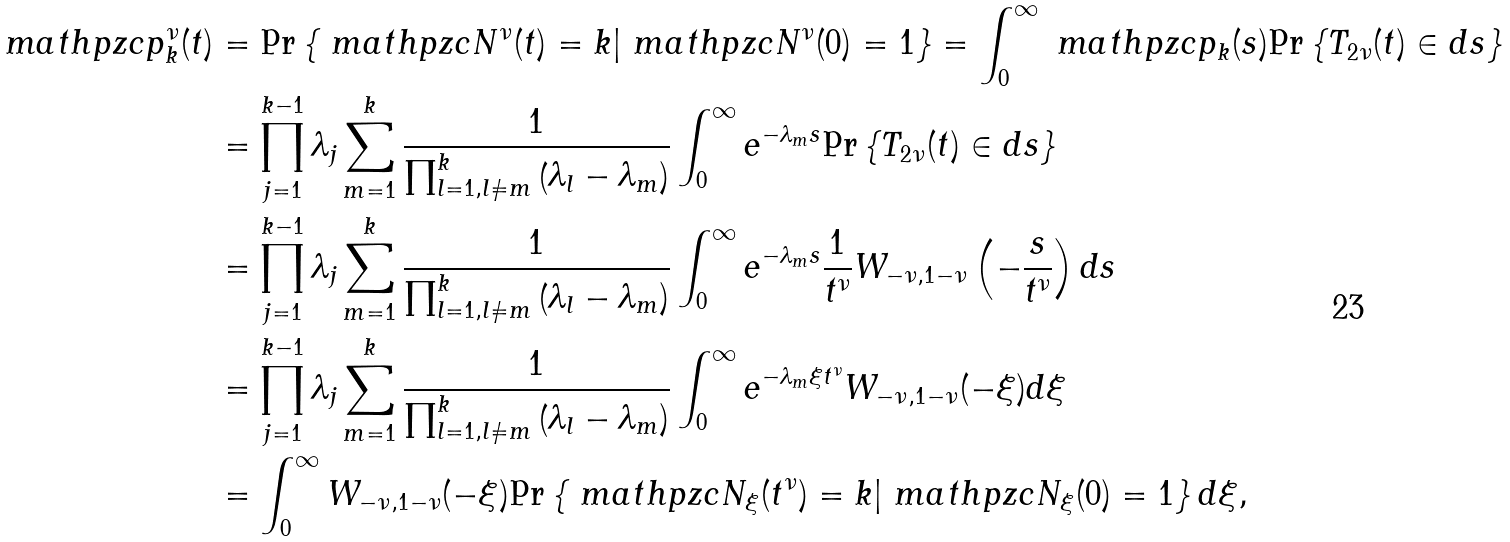<formula> <loc_0><loc_0><loc_500><loc_500>\ m a t h p z c { p } _ { k } ^ { \nu } ( t ) & = \text {Pr} \left \{ \ m a t h p z c { N } ^ { \nu } ( t ) = k | \ m a t h p z c { N } ^ { \nu } ( 0 ) = 1 \right \} = \int _ { 0 } ^ { \infty } \ m a t h p z c { p } _ { k } ( s ) \text {Pr} \left \{ T _ { 2 \nu } ( t ) \in d s \right \} \\ & = \prod _ { j = 1 } ^ { k - 1 } \lambda _ { j } \sum _ { m = 1 } ^ { k } \frac { 1 } { \prod _ { l = 1 , l \neq m } ^ { k } \left ( \lambda _ { l } - \lambda _ { m } \right ) } \int _ { 0 } ^ { \infty } e ^ { - \lambda _ { m } s } \text {Pr} \left \{ T _ { 2 \nu } ( t ) \in d s \right \} \\ & = \prod _ { j = 1 } ^ { k - 1 } \lambda _ { j } \sum _ { m = 1 } ^ { k } \frac { 1 } { \prod _ { l = 1 , l \neq m } ^ { k } \left ( \lambda _ { l } - \lambda _ { m } \right ) } \int _ { 0 } ^ { \infty } e ^ { - \lambda _ { m } s } \frac { 1 } { t ^ { \nu } } W _ { - \nu , 1 - \nu } \left ( - \frac { s } { t ^ { \nu } } \right ) d s \\ & = \prod _ { j = 1 } ^ { k - 1 } \lambda _ { j } \sum _ { m = 1 } ^ { k } \frac { 1 } { \prod _ { l = 1 , l \neq m } ^ { k } \left ( \lambda _ { l } - \lambda _ { m } \right ) } \int _ { 0 } ^ { \infty } e ^ { - \lambda _ { m } \xi t ^ { \nu } } W _ { - \nu , 1 - \nu } ( - \xi ) d \xi \\ & = \int _ { 0 } ^ { \infty } W _ { - \nu , 1 - \nu } ( - \xi ) \text {Pr} \left \{ \ m a t h p z c { N } _ { \xi } ( t ^ { \nu } ) = k | \ m a t h p z c { N } _ { \xi } ( 0 ) = 1 \right \} d \xi ,</formula> 